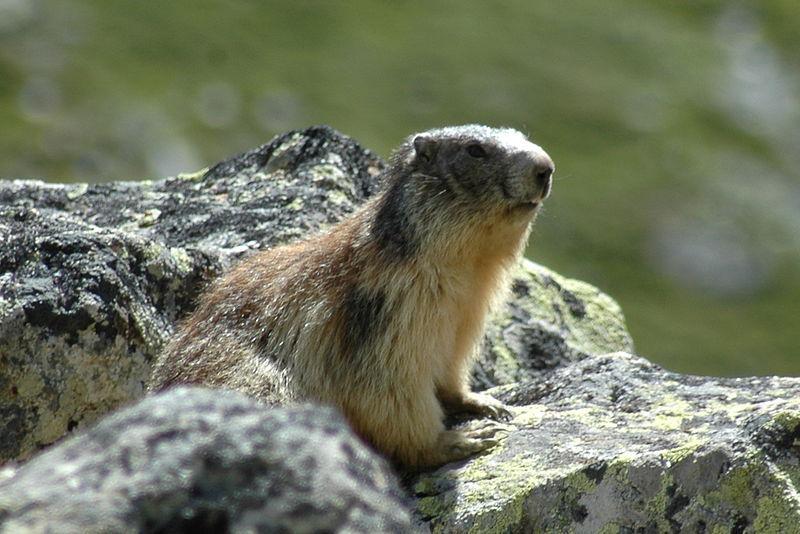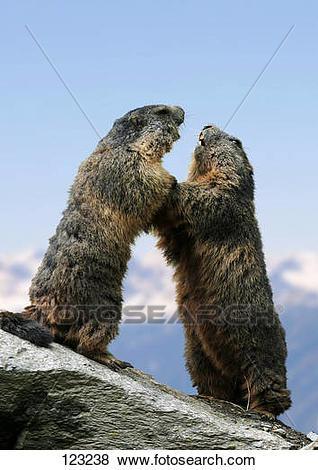The first image is the image on the left, the second image is the image on the right. Examine the images to the left and right. Is the description "There is three rodents." accurate? Answer yes or no. Yes. The first image is the image on the left, the second image is the image on the right. Assess this claim about the two images: "There are three marmots". Correct or not? Answer yes or no. Yes. 